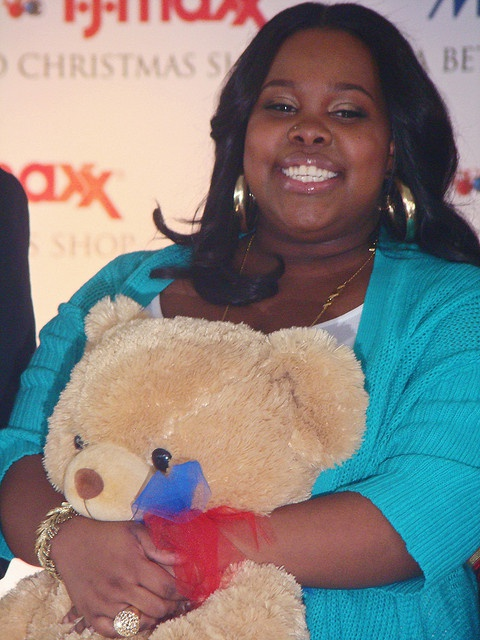Describe the objects in this image and their specific colors. I can see people in pink, tan, teal, black, and brown tones and teddy bear in pink and tan tones in this image. 